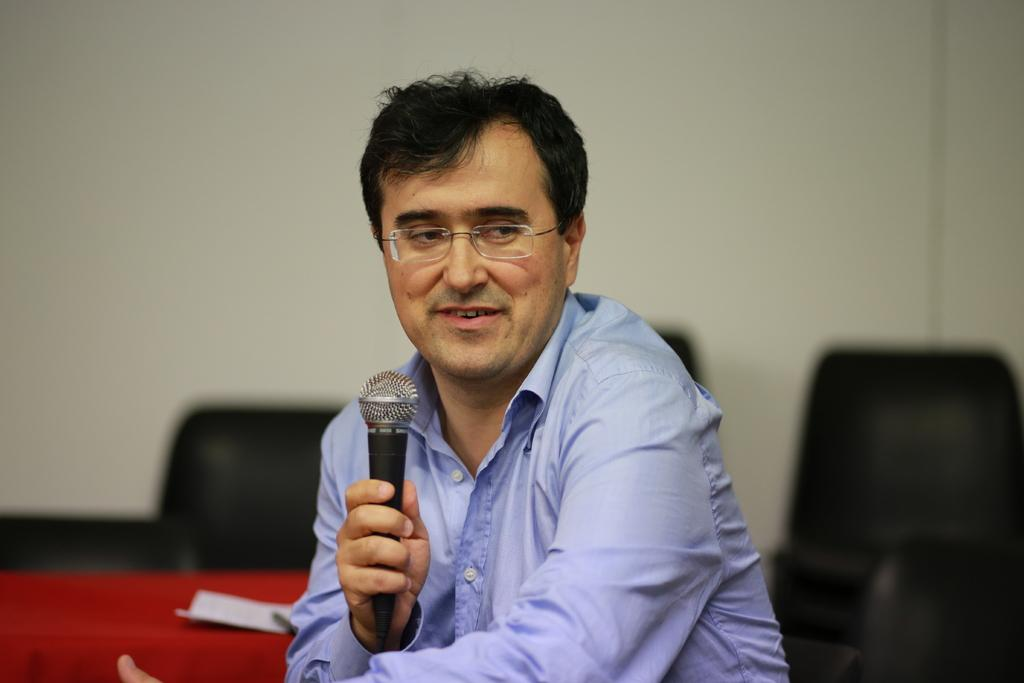Who is the main subject in the image? There is a man in the image. What is the man wearing? The man is wearing spectacles. What is the man holding in the image? The man is holding a microphone. What is the man's position in the image? The man is sitting in a chair. What is near the man in the image? The man is near a table. What can be seen in the background of the image? There is a wall in the background of the image. What type of holiday is the man celebrating in the image? There is no holiday being celebrated in the image, as the focus is on the man holding a microphone while sitting in a chair. 